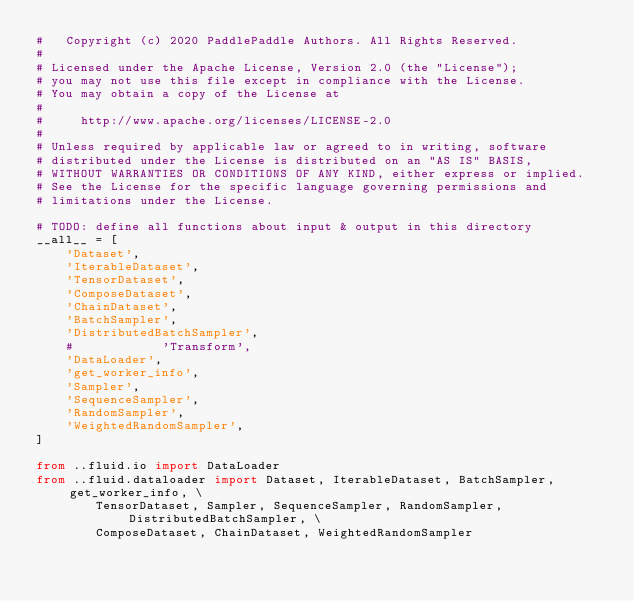Convert code to text. <code><loc_0><loc_0><loc_500><loc_500><_Python_>#   Copyright (c) 2020 PaddlePaddle Authors. All Rights Reserved.
#
# Licensed under the Apache License, Version 2.0 (the "License");
# you may not use this file except in compliance with the License.
# You may obtain a copy of the License at
#
#     http://www.apache.org/licenses/LICENSE-2.0
#
# Unless required by applicable law or agreed to in writing, software
# distributed under the License is distributed on an "AS IS" BASIS,
# WITHOUT WARRANTIES OR CONDITIONS OF ANY KIND, either express or implied.
# See the License for the specific language governing permissions and
# limitations under the License.

# TODO: define all functions about input & output in this directory 
__all__ = [
    'Dataset',
    'IterableDataset',
    'TensorDataset',
    'ComposeDataset',
    'ChainDataset',
    'BatchSampler',
    'DistributedBatchSampler',
    #            'Transform',
    'DataLoader',
    'get_worker_info',
    'Sampler',
    'SequenceSampler',
    'RandomSampler',
    'WeightedRandomSampler',
]

from ..fluid.io import DataLoader
from ..fluid.dataloader import Dataset, IterableDataset, BatchSampler, get_worker_info, \
        TensorDataset, Sampler, SequenceSampler, RandomSampler, DistributedBatchSampler, \
        ComposeDataset, ChainDataset, WeightedRandomSampler
</code> 